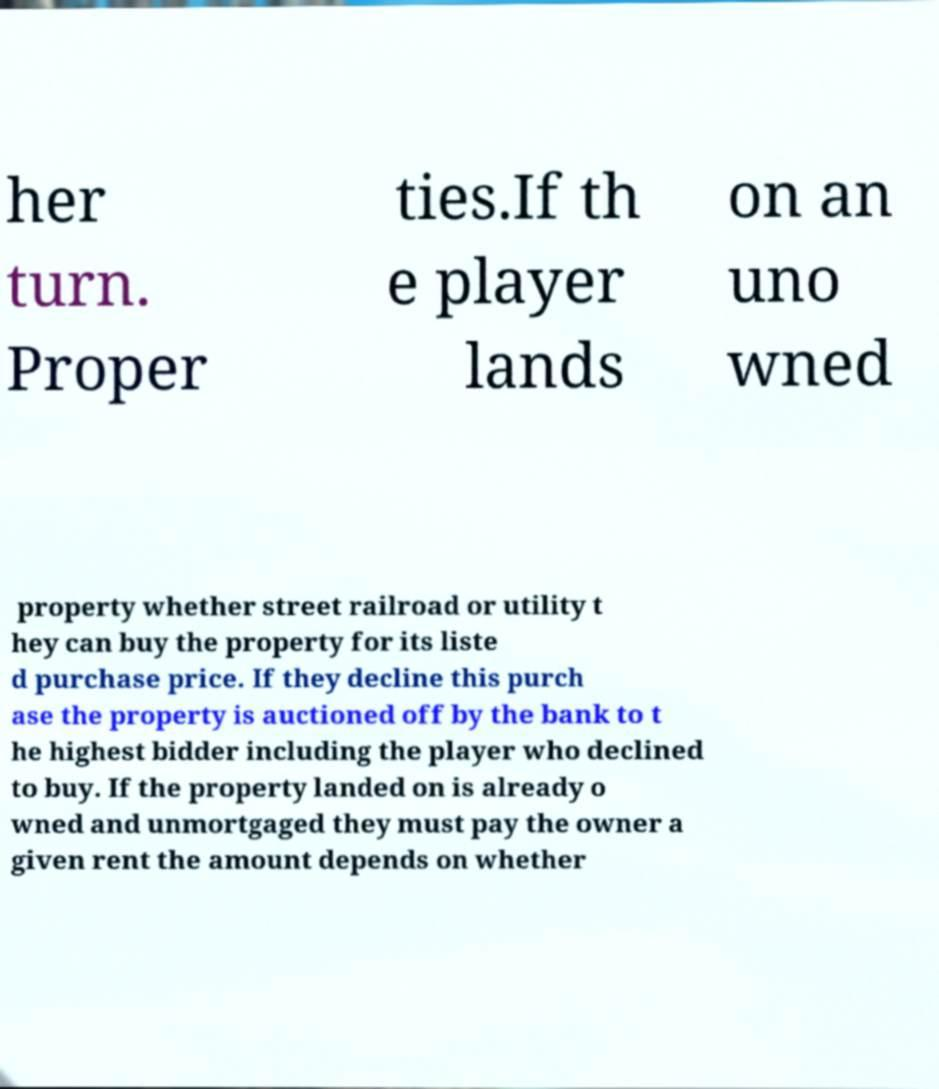What messages or text are displayed in this image? I need them in a readable, typed format. her turn. Proper ties.If th e player lands on an uno wned property whether street railroad or utility t hey can buy the property for its liste d purchase price. If they decline this purch ase the property is auctioned off by the bank to t he highest bidder including the player who declined to buy. If the property landed on is already o wned and unmortgaged they must pay the owner a given rent the amount depends on whether 